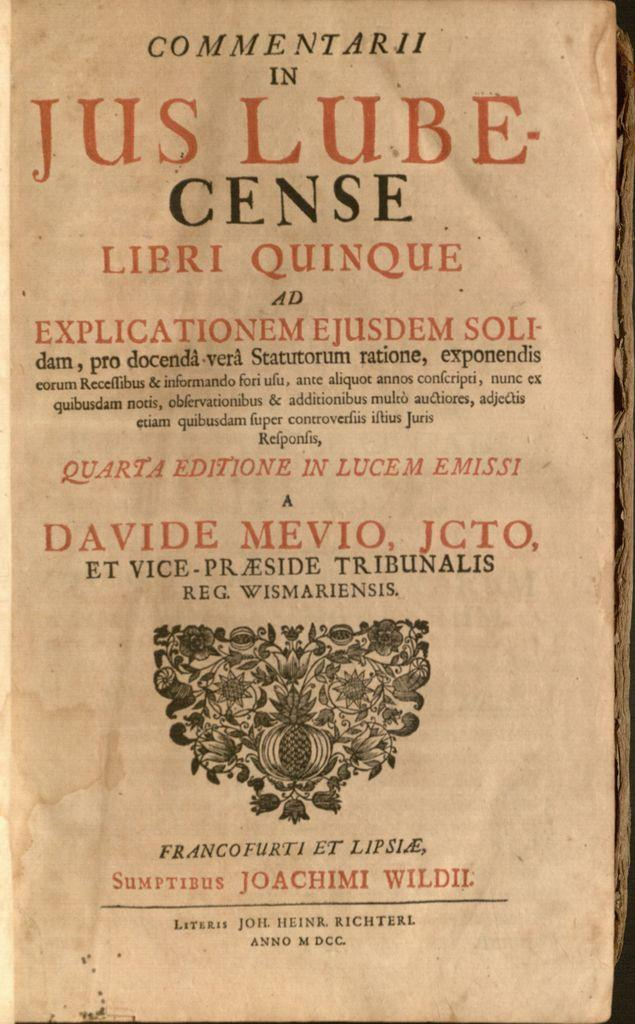<image>
Render a clear and concise summary of the photo. A page written in Latin has the first word in the title as Commentarii. 